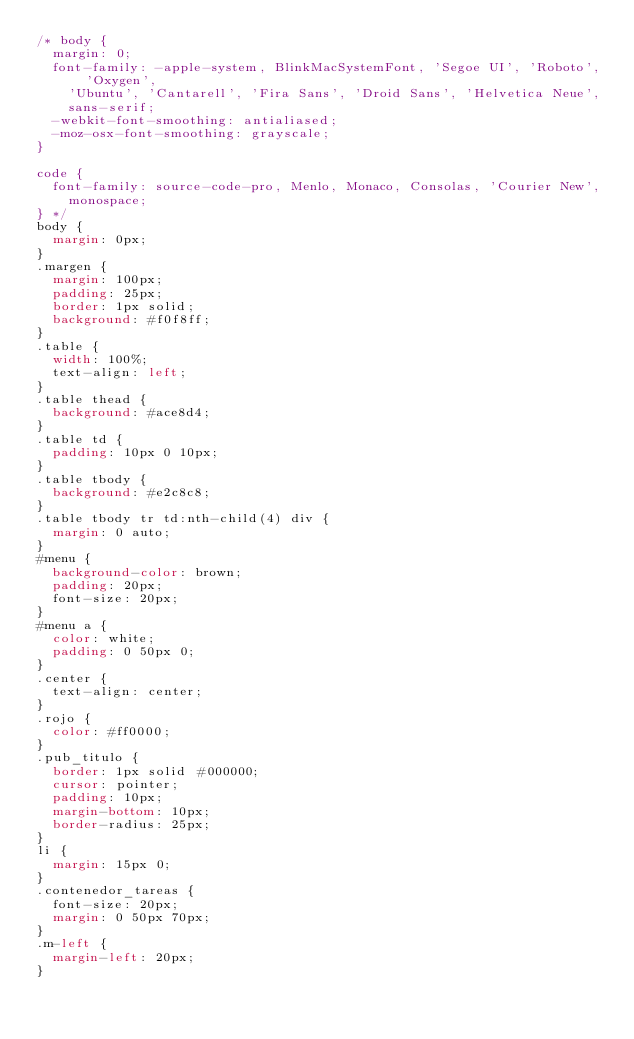<code> <loc_0><loc_0><loc_500><loc_500><_CSS_>/* body {
  margin: 0;
  font-family: -apple-system, BlinkMacSystemFont, 'Segoe UI', 'Roboto', 'Oxygen',
    'Ubuntu', 'Cantarell', 'Fira Sans', 'Droid Sans', 'Helvetica Neue',
    sans-serif;
  -webkit-font-smoothing: antialiased;
  -moz-osx-font-smoothing: grayscale;
}

code {
  font-family: source-code-pro, Menlo, Monaco, Consolas, 'Courier New',
    monospace;
} */
body {
  margin: 0px;
}
.margen {
  margin: 100px;
  padding: 25px;
  border: 1px solid;
  background: #f0f8ff;
}
.table {
  width: 100%;
  text-align: left;
}
.table thead {
  background: #ace8d4;
}
.table td {
  padding: 10px 0 10px;
}
.table tbody {
  background: #e2c8c8;
}
.table tbody tr td:nth-child(4) div {
  margin: 0 auto;
}
#menu {
  background-color: brown;
  padding: 20px;
  font-size: 20px;
}
#menu a {
  color: white;
  padding: 0 50px 0;
}
.center {
  text-align: center;
}
.rojo {
  color: #ff0000;
}
.pub_titulo {
  border: 1px solid #000000;
  cursor: pointer;
  padding: 10px;
  margin-bottom: 10px;
  border-radius: 25px;
}
li {
  margin: 15px 0;
}
.contenedor_tareas {
  font-size: 20px;
  margin: 0 50px 70px;
}
.m-left {
  margin-left: 20px;
}
</code> 